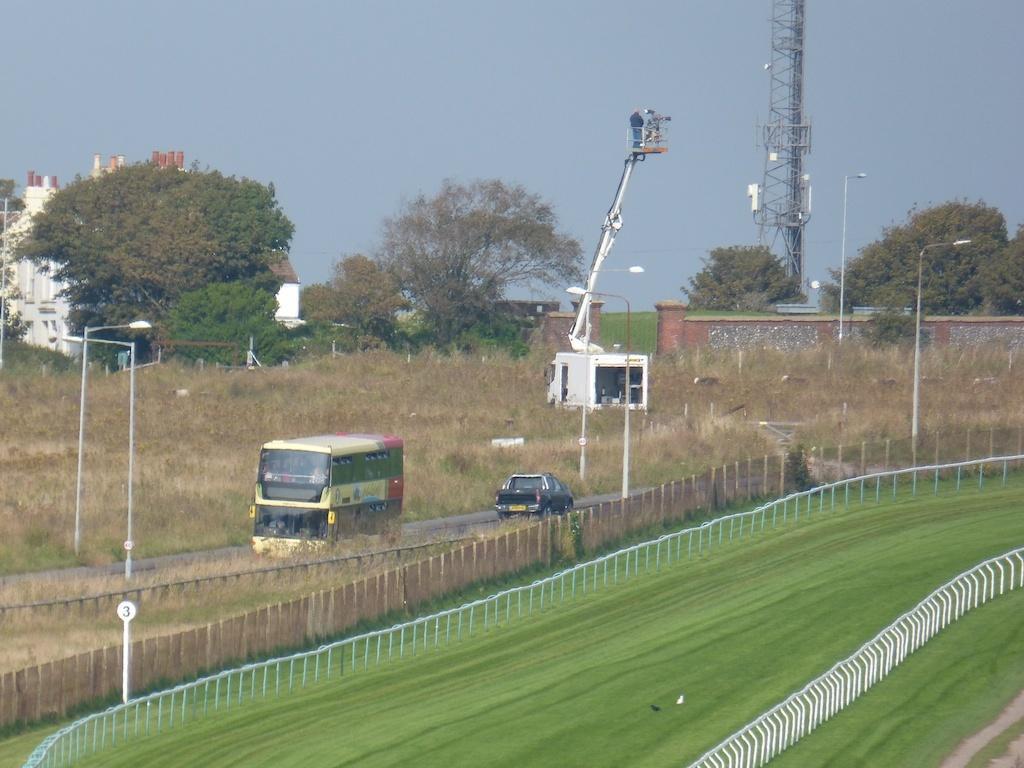Please provide a concise description of this image. In this picture I can see a car and a Double Decker bus on the road, there are poles, lights, fence, grass, there is a building, there are trees, there is an electric tower, and in the background there is the sky. 